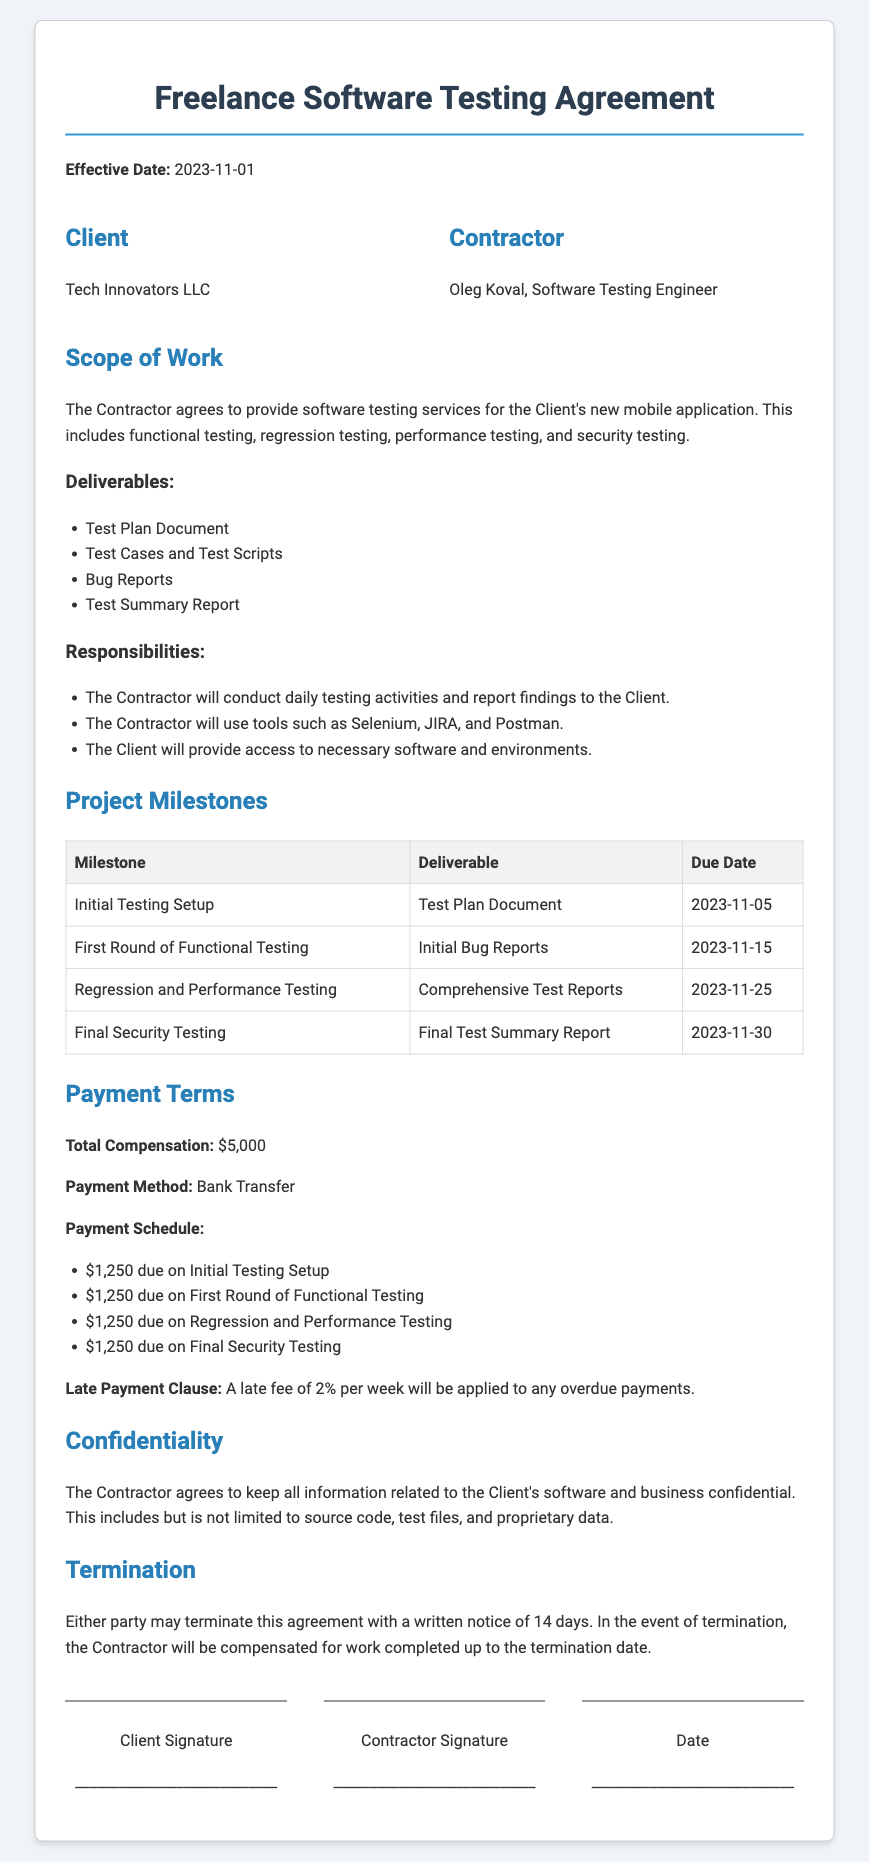What is the effective date of the agreement? The effective date is stated clearly in the document as the starting date for the agreement.
Answer: 2023-11-01 Who is the contractor? The document specifies the name and title of the person providing the testing services, identifying them as the contractor.
Answer: Oleg Koval, Software Testing Engineer What is the total compensation for the project? The total compensation is stated in the payment terms section, summarizing the financial agreement between the parties.
Answer: $5,000 What is the due date for the Initial Testing Setup milestone? The due date for each milestone is provided in the project milestones table, which includes specific dates for deliverables.
Answer: 2023-11-05 What percentage is the late payment fee? The late payment clause outlines the penalty applied to overdue payments, expressing it as a percentage of the amount due.
Answer: 2% What is one of the responsibilities of the contractor? The document lists specific duties expected of the contractor in the responsibilities section, which explains what the contractor must do.
Answer: Conduct daily testing activities How many deliverables are listed in the Scope of Work? The number of deliverables is included in the deliverables section, outlining the outputs expected from the contractor.
Answer: 4 What is the payment method specified in the agreement? The method of payment is mentioned explicitly in the payment terms, indicating how the contractor will receive payment.
Answer: Bank Transfer What notice period is required for termination of the agreement? The termination section specifies the advance notice required by either party to legally end the contract.
Answer: 14 days 